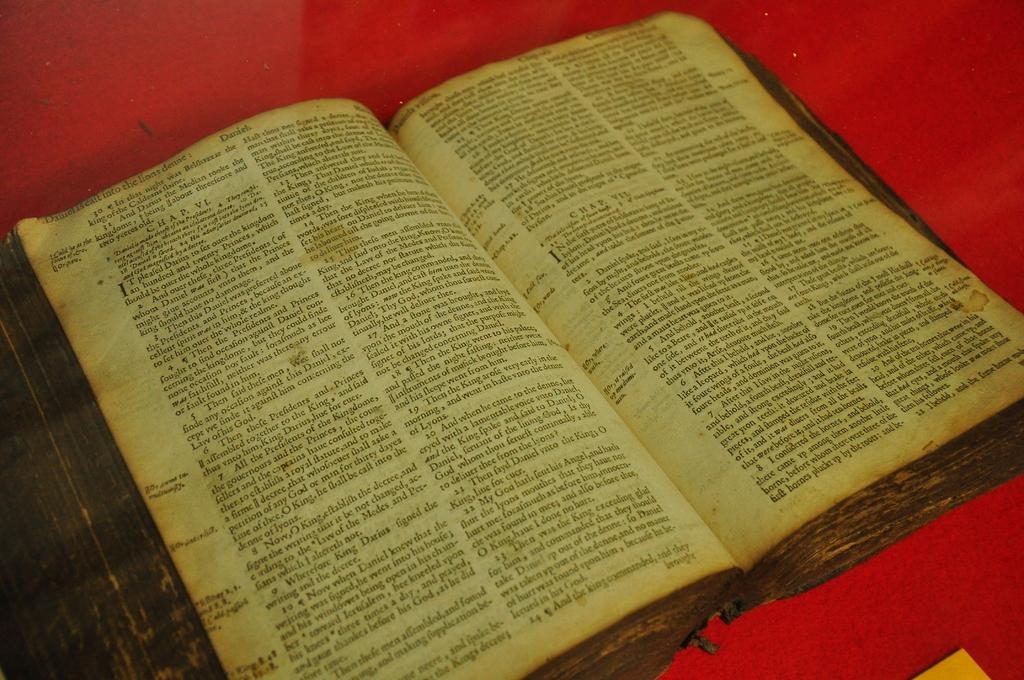<image>
Create a compact narrative representing the image presented. A very old book is opened to the beginning of chapter 7. 